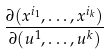Convert formula to latex. <formula><loc_0><loc_0><loc_500><loc_500>\frac { \partial ( x ^ { i _ { 1 } } , \dots , x ^ { i _ { k } } ) } { \partial ( u ^ { 1 } , \dots , u ^ { k } ) }</formula> 